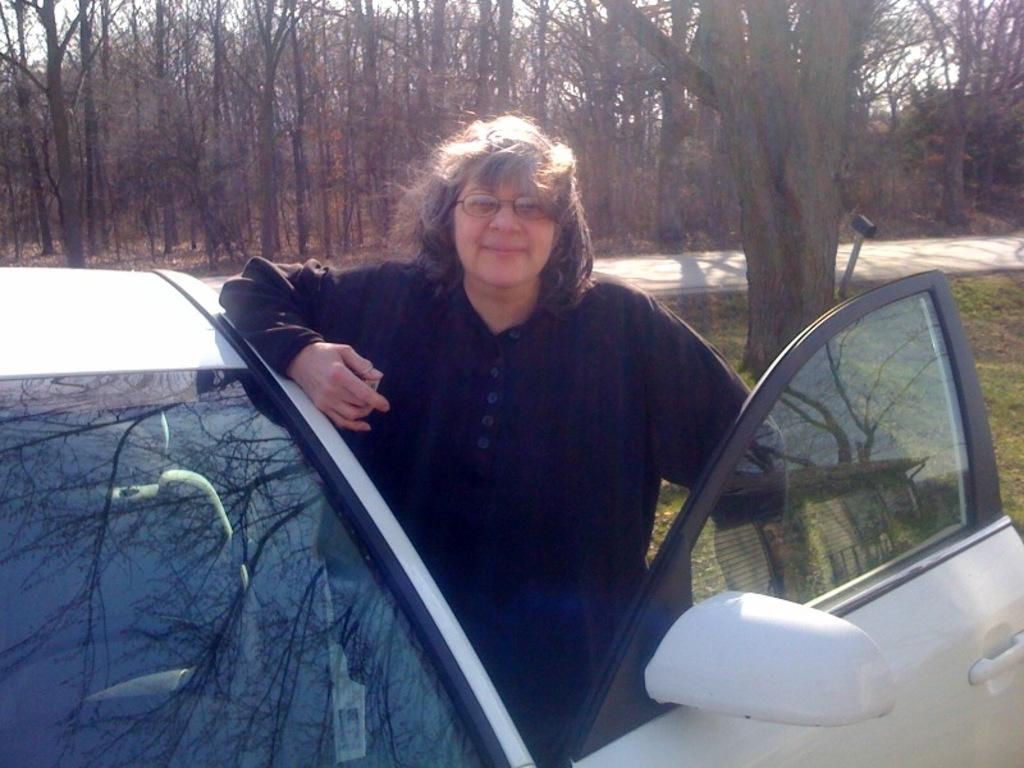Who is present in the image? There is a woman in the image. What else can be seen in the image besides the woman? There is a vehicle and trees in the image. Where is the market located in the image? There is no market present in the image. What type of cream is being used by the woman in the image? There is no cream visible in the image, and the woman's actions are not described. 